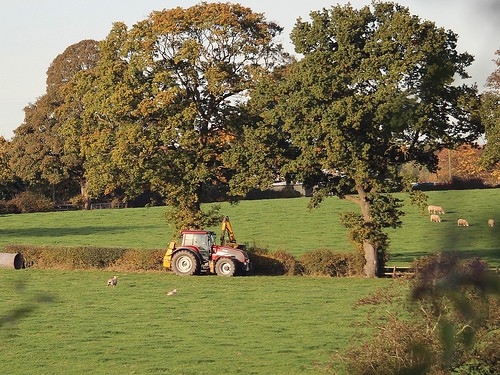<image>
Is the tractor under the tree? Yes. The tractor is positioned underneath the tree, with the tree above it in the vertical space. Where is the tree in relation to the tractor? Is it behind the tractor? No. The tree is not behind the tractor. From this viewpoint, the tree appears to be positioned elsewhere in the scene. Is the tree behind the grass? No. The tree is not behind the grass. From this viewpoint, the tree appears to be positioned elsewhere in the scene. Is the tractor behind the sheep? No. The tractor is not behind the sheep. From this viewpoint, the tractor appears to be positioned elsewhere in the scene. 